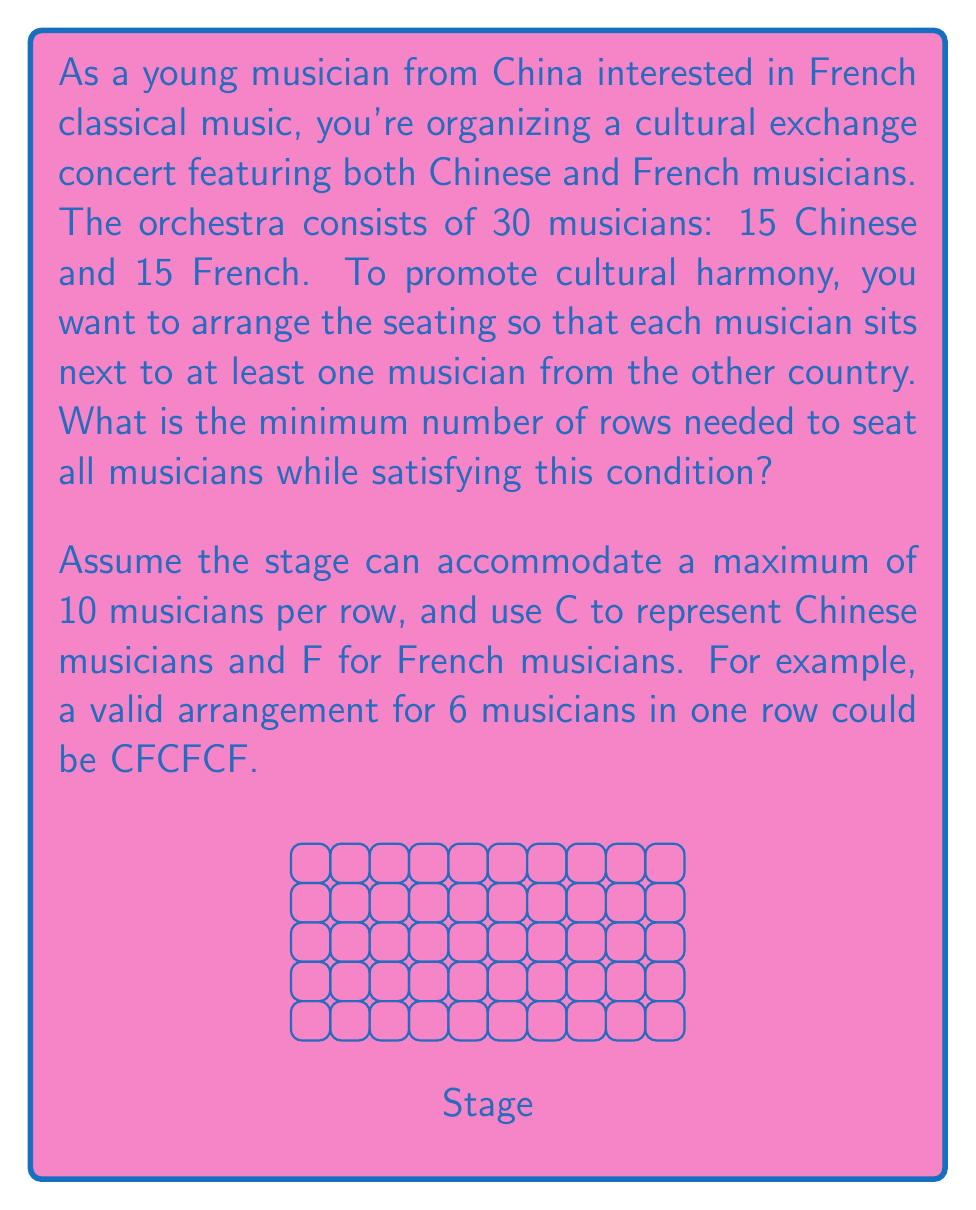Show me your answer to this math problem. Let's approach this step-by-step:

1) First, we need to understand the constraint: each musician must sit next to at least one musician from the other country. This means we can't have two musicians of the same nationality sitting next to each other at the ends of rows.

2) The most efficient arrangement would be to alternate Chinese and French musicians as much as possible. The ideal pattern would be CFCFCF...

3) With 15 musicians from each country, we have a total of 30 musicians to arrange.

4) Let's start filling rows with the maximum capacity of 10 musicians each:

   Row 1: CFCFCFCFCF (10 musicians)
   Row 2: CFCFCFCFCF (10 musicians)
   Row 3: CFCFCFCFCF (10 musicians)

5) After three full rows, we've placed 30 musicians, which is exactly the number we need.

6) Let's verify:
   - Total musicians placed: 10 + 10 + 10 = 30
   - Chinese musicians: 5 + 5 + 5 = 15
   - French musicians: 5 + 5 + 5 = 15

7) This arrangement satisfies all conditions:
   - Each musician sits next to at least one musician from the other country
   - All 30 musicians are seated
   - No row exceeds the maximum capacity of 10

Therefore, the minimum number of rows needed is 3.
Answer: 3 rows 